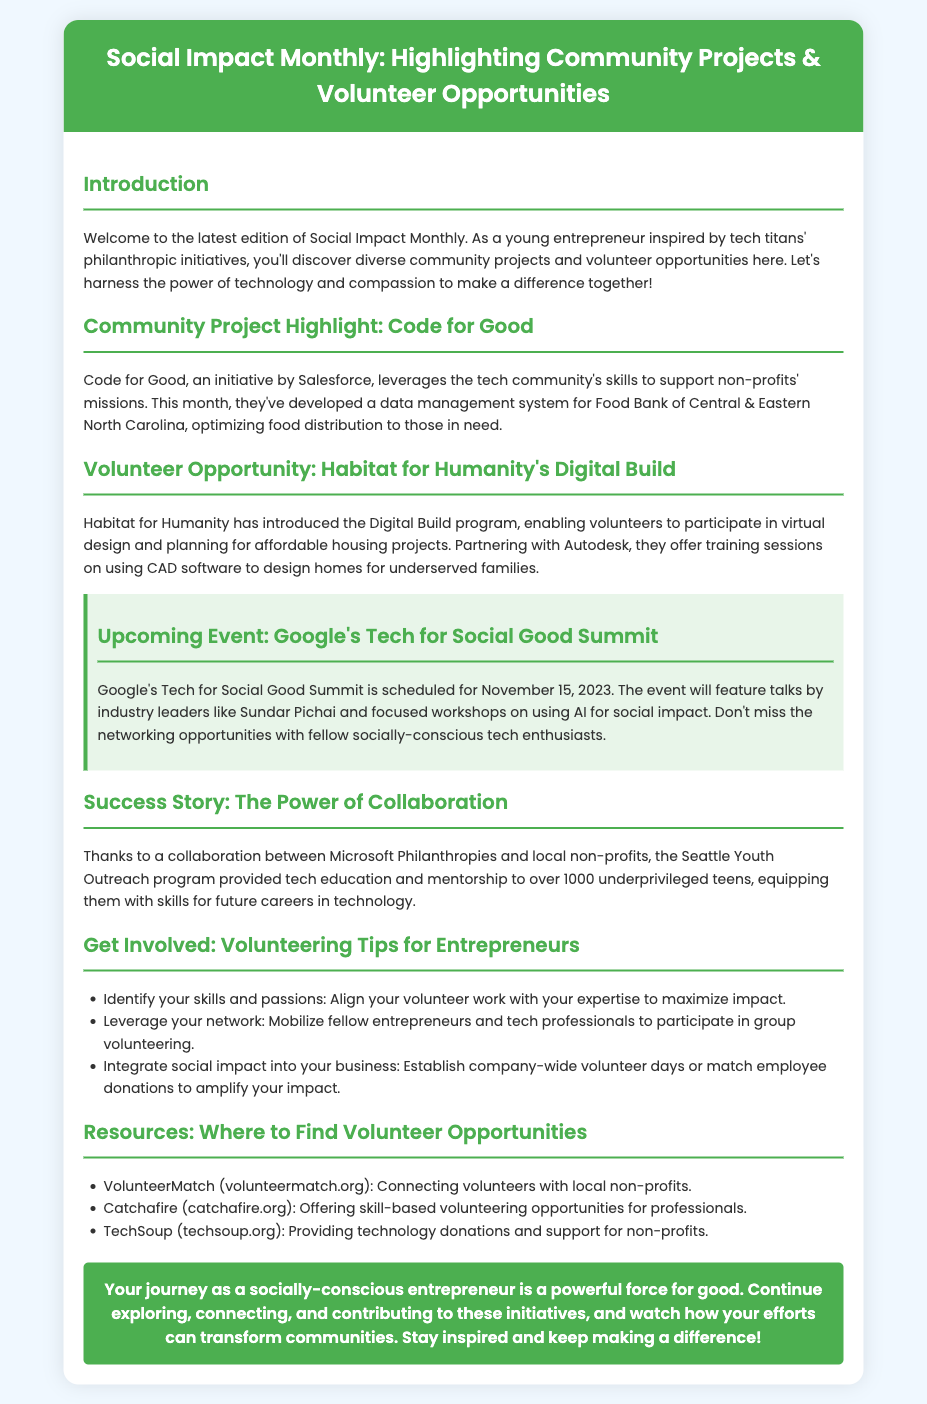What is the name of the community project highlighted this month? The document mentions "Code for Good" as the community project highlighted this month.
Answer: Code for Good Who introduced the Digital Build program? "Habitat for Humanity" is named in the document as introducing the Digital Build program.
Answer: Habitat for Humanity When is Google's Tech for Social Good Summit scheduled? The document states that the summit is scheduled for November 15, 2023.
Answer: November 15, 2023 How many underprivileged teens received tech education through the Seattle Youth Outreach program? The document indicates that over 1000 underprivileged teens were provided tech education.
Answer: Over 1000 What type of volunteering opportunities does Catchafire offer? Catchafire is mentioned as providing "skill-based volunteering opportunities for professionals."
Answer: Skill-based volunteering What key element should entrepreneurs leverage according to the volunteering tips? The document suggests that entrepreneurs should leverage their "network" for group volunteering.
Answer: Network Which organization helps connect volunteers with local non-profits? "VolunteerMatch" is identified in the document as the organization that connects volunteers with local non-profits.
Answer: VolunteerMatch What type of support does TechSoup provide? The document mentions that TechSoup provides "technology donations and support for non-profits."
Answer: Technology donations What is the color scheme of the container in the document? The document describes the background color of the container as "white."
Answer: White What is the main theme of the document? The primary theme centers around "community projects and volunteer opportunities."
Answer: Community projects and volunteer opportunities 